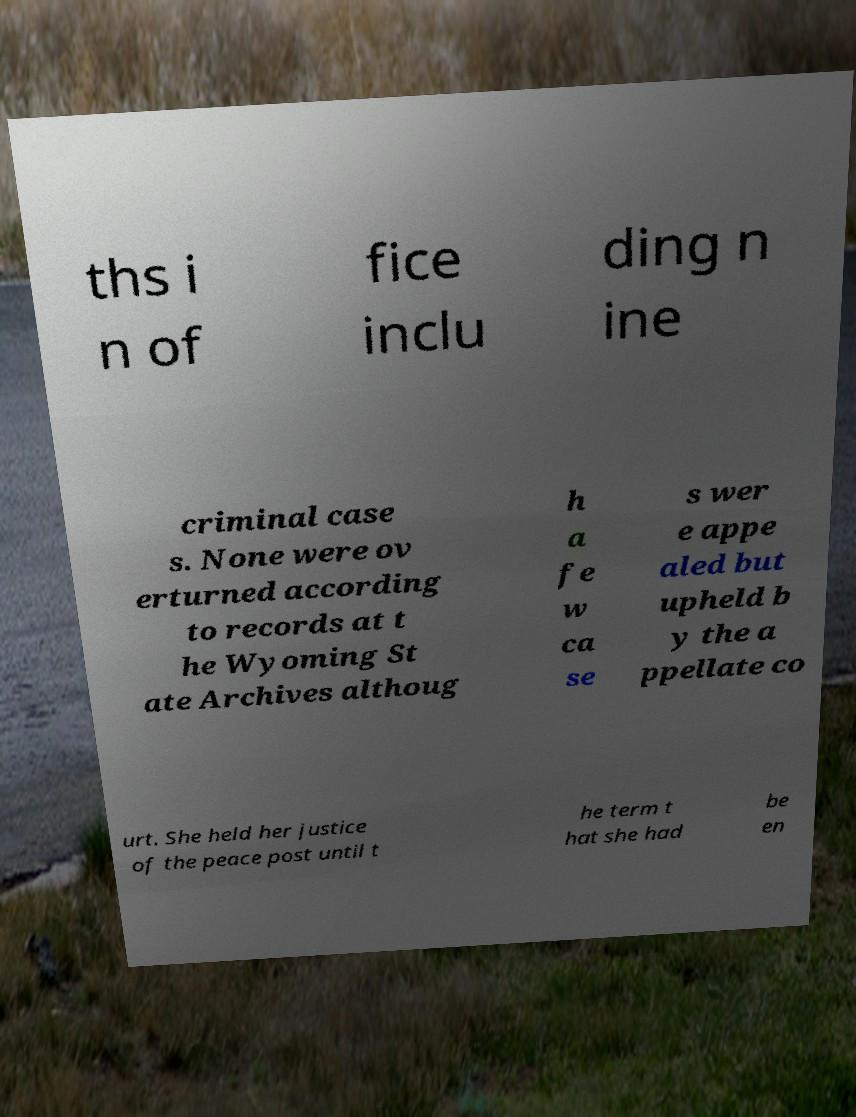Can you accurately transcribe the text from the provided image for me? ths i n of fice inclu ding n ine criminal case s. None were ov erturned according to records at t he Wyoming St ate Archives althoug h a fe w ca se s wer e appe aled but upheld b y the a ppellate co urt. She held her justice of the peace post until t he term t hat she had be en 